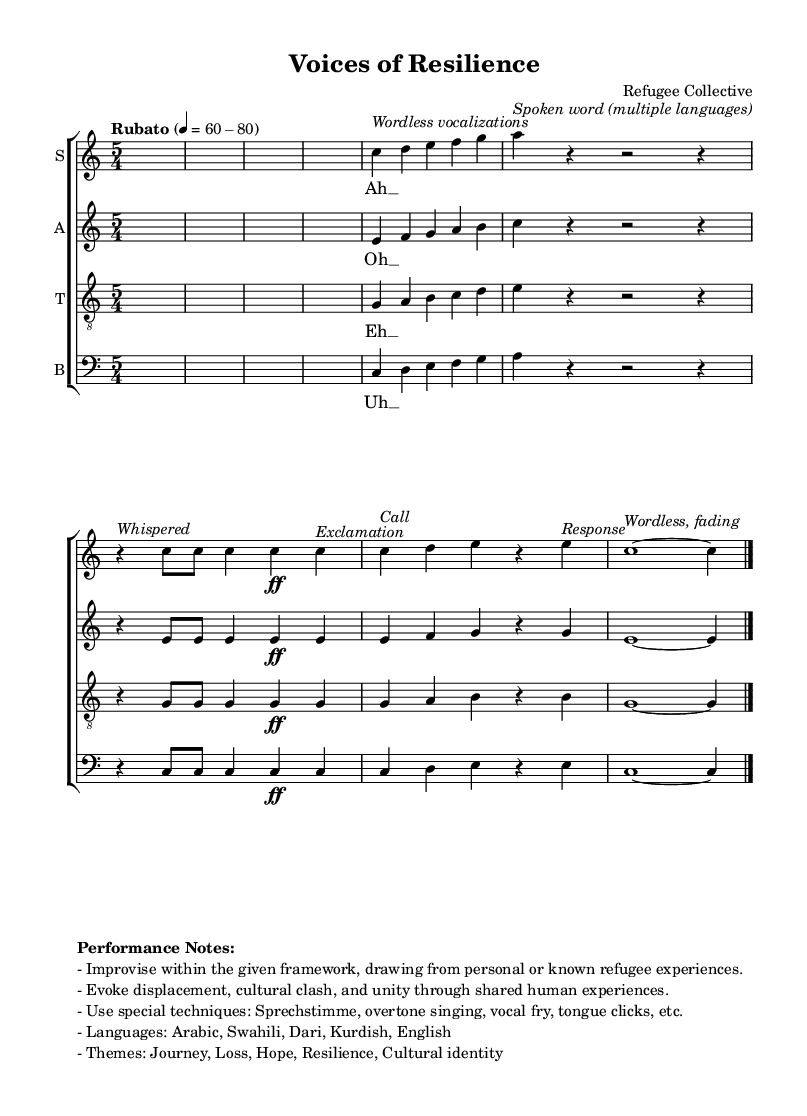What is the time signature of this music? The time signature is found at the beginning of the score, which indicates how many beats are in each measure. Here, it is written as 5/4, meaning there are five beats per measure and the quarter note gets one beat.
Answer: 5/4 What is the tempo marking in this music? The tempo marking is stated in words, which provide guidance on the speed of the piece. In this case, it is "Rubato," indicating a flexible tempo, with a specific beat range mentioned as 60-80 beats per minute.
Answer: Rubato How many vocal parts are scored in this piece? The score displays a staff for each of the four vocal parts: soprano, alto, tenor, and bass. The indication of separate staves confirms the presence of four distinct parts.
Answer: Four What vocal techniques are suggested in the performance notes? The performance notes outline specific vocal techniques to be used, such as Sprechstimme, overtone singing, vocal fry, and tongue clicks. These specialized techniques enhance the experimental nature of the piece.
Answer: Sprechstimme, overtone singing, vocal fry, tongue clicks What thematic elements are present in this composition? The performance notes detail thematic elements to be explored within the piece, including journey, loss, hope, resilience, and cultural identity. These themes are integral to reflecting the experiences of refugees.
Answer: Journey, loss, hope, resilience, cultural identity What languages are incorporated in the vocalizations of this work? The score specifies a range of languages included in the vocalizations, which are noted to be Arabic, Swahili, Dari, Kurdish, and English. These languages signify the multicultural influences of the piece.
Answer: Arabic, Swahili, Dari, Kurdish, English 